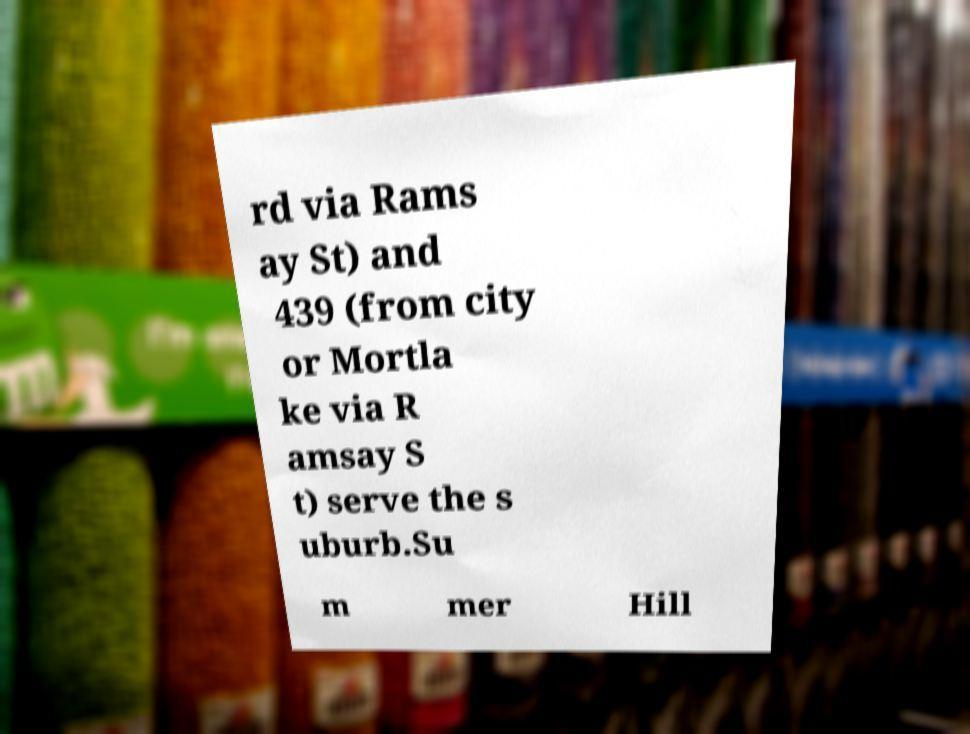Can you accurately transcribe the text from the provided image for me? rd via Rams ay St) and 439 (from city or Mortla ke via R amsay S t) serve the s uburb.Su m mer Hill 